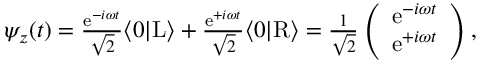<formula> <loc_0><loc_0><loc_500><loc_500>\begin{array} { r } { \psi _ { z } ( t ) = \frac { e ^ { - i \omega t } } { \sqrt { 2 } } \langle 0 | L \rangle + \frac { e ^ { + i \omega t } } { \sqrt { 2 } } \langle 0 | R \rangle = \frac { 1 } { \sqrt { 2 } } \left ( \begin{array} { c } { e ^ { - i \omega t } } \\ { e ^ { + i \omega t } } \end{array} \right ) , } \end{array}</formula> 